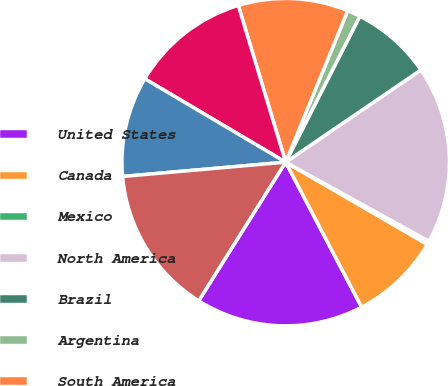<chart> <loc_0><loc_0><loc_500><loc_500><pie_chart><fcel>United States<fcel>Canada<fcel>Mexico<fcel>North America<fcel>Brazil<fcel>Argentina<fcel>South America<fcel>United Kingdom<fcel>Germany<fcel>EU21 (d)<nl><fcel>16.6%<fcel>8.95%<fcel>0.34%<fcel>17.55%<fcel>7.99%<fcel>1.3%<fcel>10.86%<fcel>11.82%<fcel>9.9%<fcel>14.69%<nl></chart> 